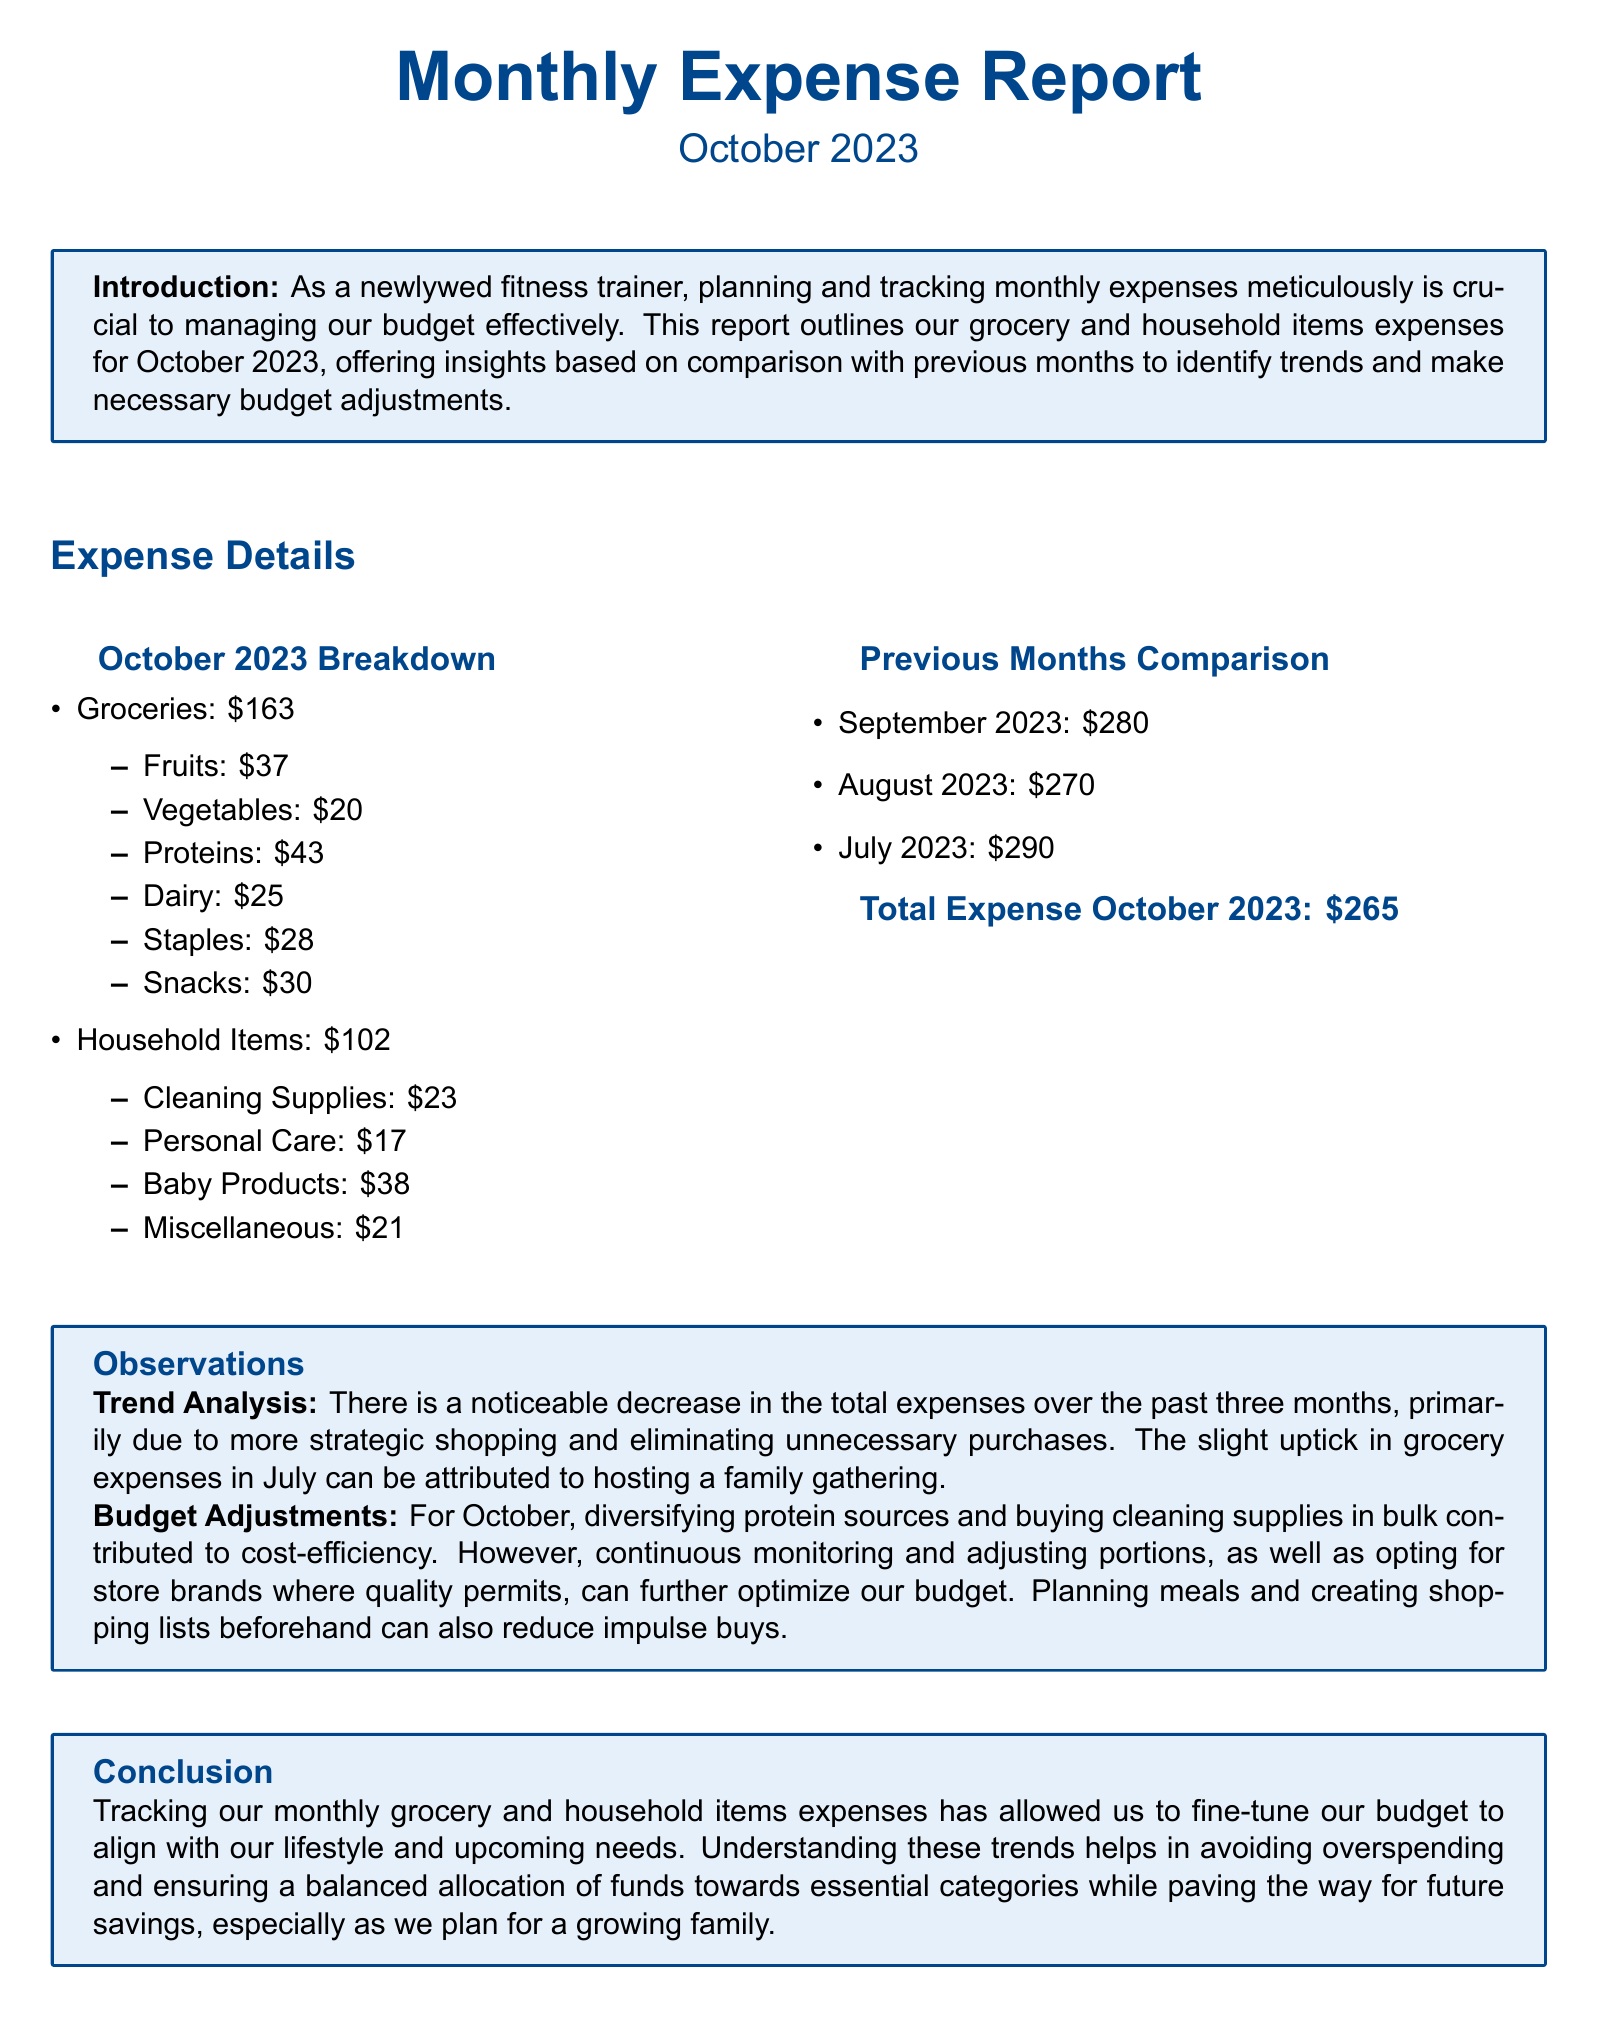What was the total expense for October 2023? The total expense is listed as the sum of grocery and household items in October 2023, which is $163 + $102.
Answer: $265 How much was spent on Baby Products in October 2023? The amount spent on Baby Products is specified under Household Items.
Answer: $38 What was the grocery expense in September 2023? The total grocery expense is not specified for September; however, the overall expense is given.
Answer: Not provided What category had the highest spending in October 2023? The category with the highest spending in October is identified within the grocery breakdown.
Answer: Proteins What is the total grocery expense for October 2023? The total grocery expense is the sum of the individual grocery categories listed in the breakdown for October 2023.
Answer: $163 Which month had the highest overall expenses? The total expenses for previous months are compared, indicating which month had the largest total.
Answer: July 2023 How much is spent on cleaning supplies in October 2023? The expense for cleaning supplies is provided within the Household Items breakdown.
Answer: $23 What observation suggests a strategy for budget adjustments? The observation discusses strategic shopping and adjustments made to reduce expenses in October compared to previous months.
Answer: Strategic shopping What was the expense trend over the last three months? The trend analysis reveals how the total expenses changed over the past months described in the report.
Answer: Decrease 